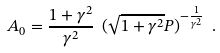Convert formula to latex. <formula><loc_0><loc_0><loc_500><loc_500>A _ { 0 } = \frac { 1 + \gamma ^ { 2 } } { \gamma ^ { 2 } } \ ( \sqrt { 1 + \gamma ^ { 2 } } P ) ^ { - \frac { 1 } { \gamma ^ { 2 } } } \ .</formula> 